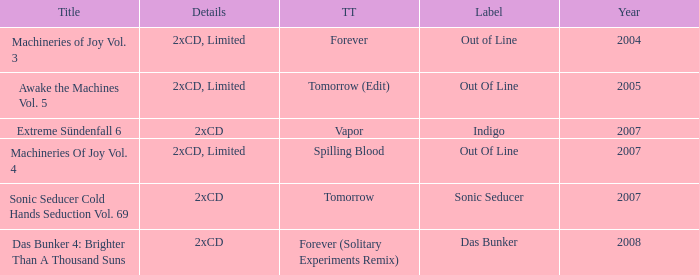Which label has a year older than 2004 and a 2xcd detail as well as the sonic seducer cold hands seduction vol. 69 title? Sonic Seducer. 